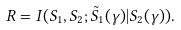<formula> <loc_0><loc_0><loc_500><loc_500>R = I ( S _ { 1 } , S _ { 2 } ; \tilde { S } _ { 1 } ( \gamma ) | S _ { 2 } ( \gamma ) ) .</formula> 